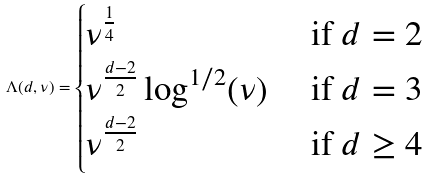<formula> <loc_0><loc_0><loc_500><loc_500>\Lambda ( d , \nu ) = \begin{cases} \nu ^ { \frac { 1 } { 4 } } & \text { if $d=2$} \\ \nu ^ { \frac { d - 2 } { 2 } } \log ^ { 1 / 2 } ( \nu ) & \text { if $d=3$} \\ \nu ^ { \frac { d - 2 } { 2 } } & \text { if $d\geq 4$} \end{cases}</formula> 